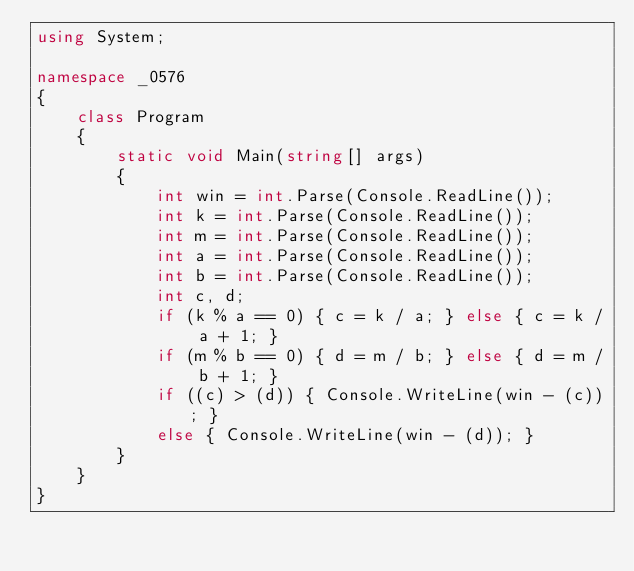Convert code to text. <code><loc_0><loc_0><loc_500><loc_500><_C#_>using System;

namespace _0576
{
    class Program
    {
        static void Main(string[] args)
        {
            int win = int.Parse(Console.ReadLine());
            int k = int.Parse(Console.ReadLine());
            int m = int.Parse(Console.ReadLine());
            int a = int.Parse(Console.ReadLine());
            int b = int.Parse(Console.ReadLine());
            int c, d;
            if (k % a == 0) { c = k / a; } else { c = k / a + 1; }
            if (m % b == 0) { d = m / b; } else { d = m / b + 1; }
            if ((c) > (d)) { Console.WriteLine(win - (c)); }
            else { Console.WriteLine(win - (d)); }
        }
    }
}</code> 